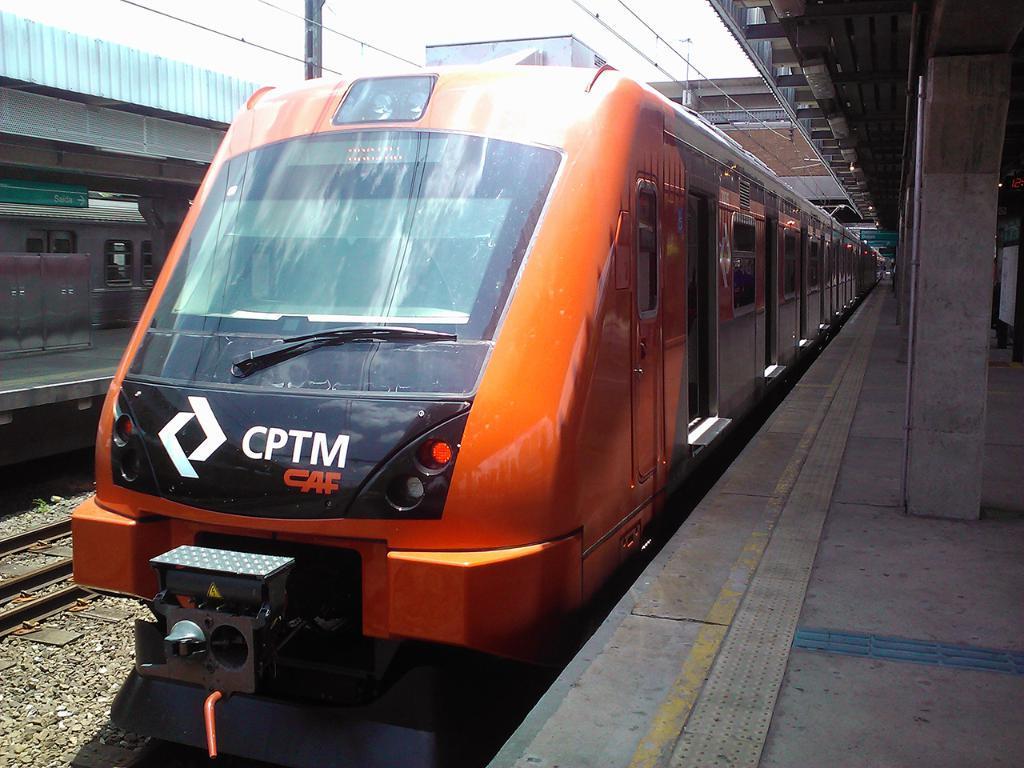Please provide a concise description of this image. In the middle of the image we can see a train, beside the train we can find platforms on the left and right side of the image, in the background we can see few cables, pole and a building. 